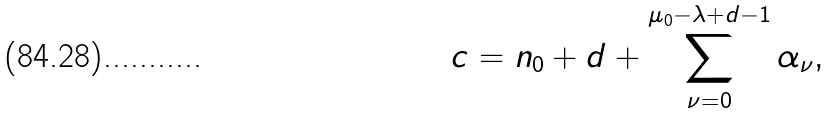<formula> <loc_0><loc_0><loc_500><loc_500>c = n _ { 0 } + d + \sum _ { \nu = 0 } ^ { \mu _ { 0 } - \lambda + d - 1 } \alpha _ { \nu } ,</formula> 